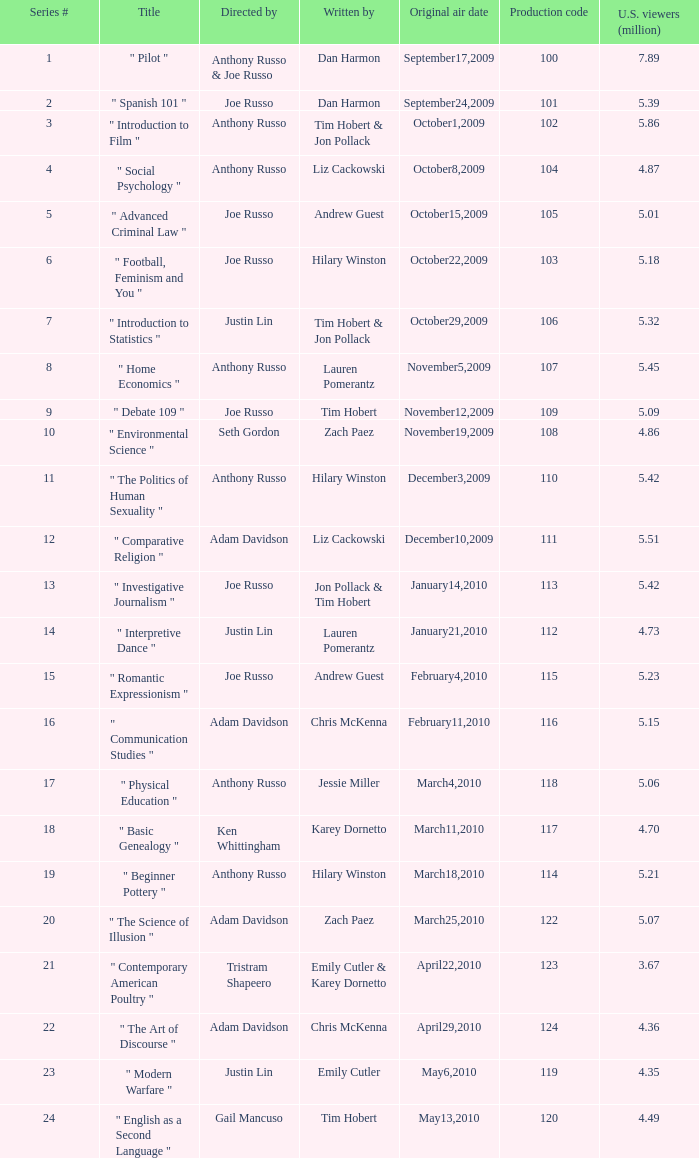What is the original air date when the u.s. viewers in millions was 5.39? September24,2009. 